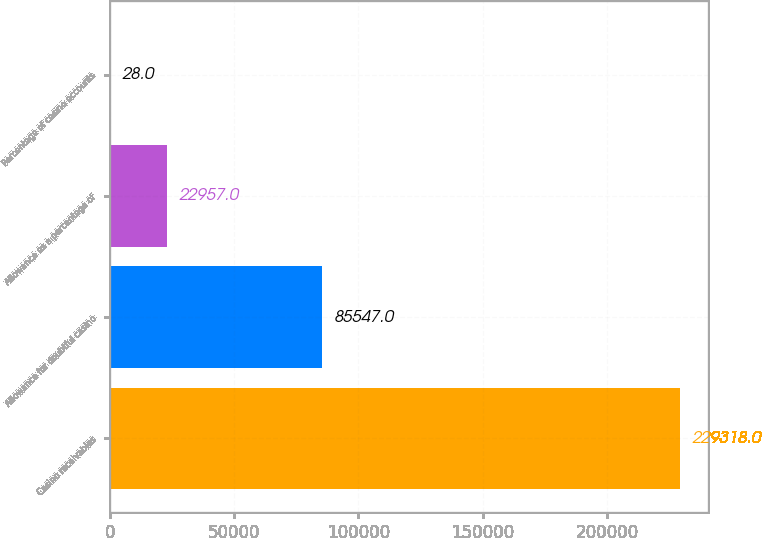Convert chart to OTSL. <chart><loc_0><loc_0><loc_500><loc_500><bar_chart><fcel>Casino receivables<fcel>Allowance for doubtful casino<fcel>Allowance as a percentage of<fcel>Percentage of casino accounts<nl><fcel>229318<fcel>85547<fcel>22957<fcel>28<nl></chart> 